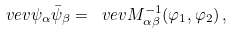<formula> <loc_0><loc_0><loc_500><loc_500>\ v e v { \psi _ { \alpha } \bar { \psi } _ { \beta } } = \ v e v { M ^ { - 1 } _ { \alpha \beta } ( \varphi _ { 1 } , \varphi _ { 2 } ) } \, ,</formula> 